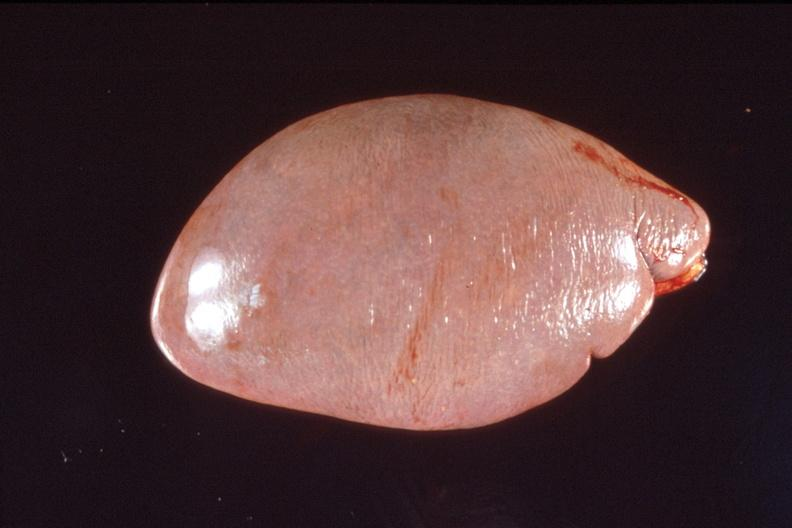s hematologic present?
Answer the question using a single word or phrase. Yes 